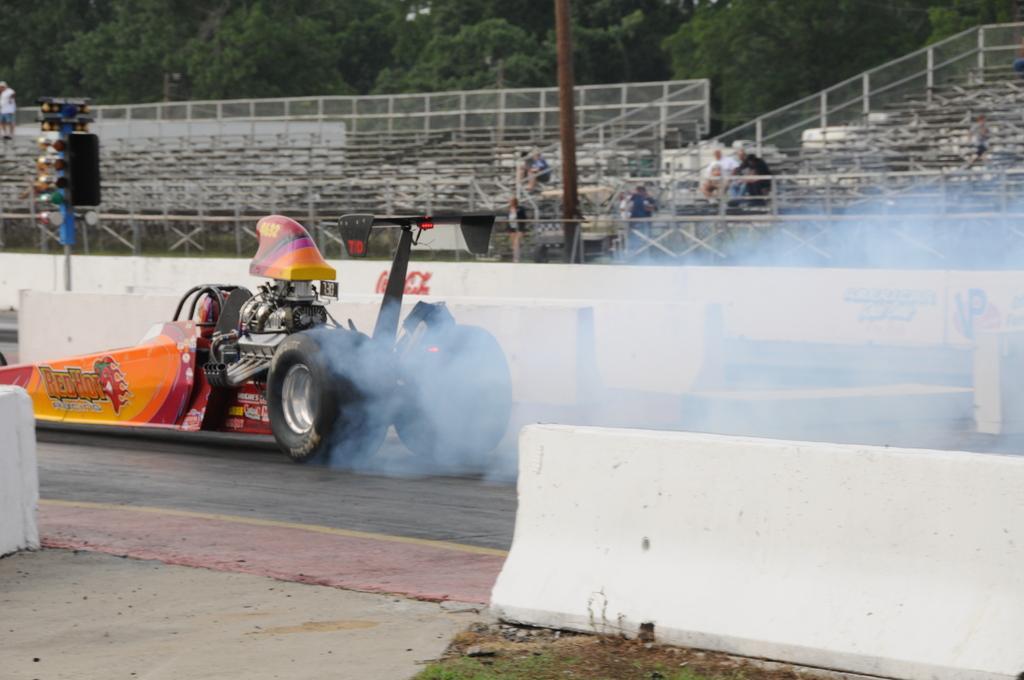How would you summarize this image in a sentence or two? In this image I can see a vehicle which is in orange and yellow color, at back I can see few poles, chairs and some persons sitting, at back I can also see trees in green color. 